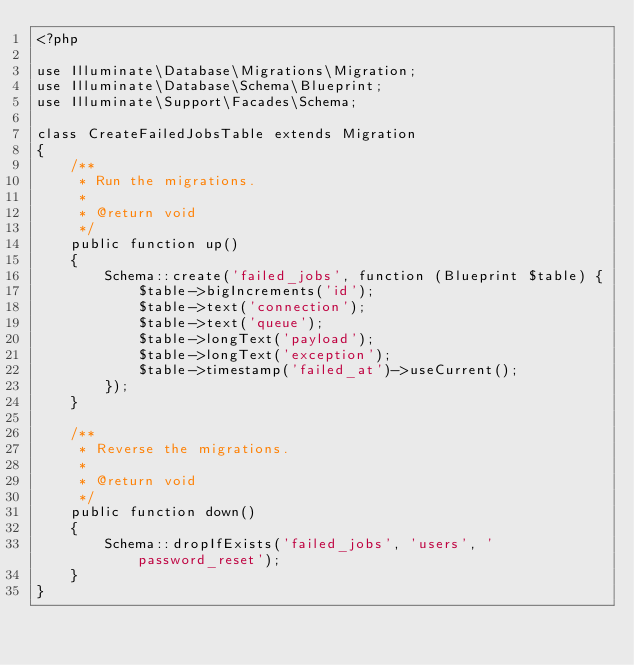<code> <loc_0><loc_0><loc_500><loc_500><_PHP_><?php

use Illuminate\Database\Migrations\Migration;
use Illuminate\Database\Schema\Blueprint;
use Illuminate\Support\Facades\Schema;

class CreateFailedJobsTable extends Migration
{
    /**
     * Run the migrations.
     *
     * @return void
     */
    public function up()
    {
        Schema::create('failed_jobs', function (Blueprint $table) {
            $table->bigIncrements('id');
            $table->text('connection');
            $table->text('queue');
            $table->longText('payload');
            $table->longText('exception');
            $table->timestamp('failed_at')->useCurrent();
        });
    }

    /**
     * Reverse the migrations.
     *
     * @return void
     */
    public function down()
    {
        Schema::dropIfExists('failed_jobs', 'users', 'password_reset');
    }
}
</code> 